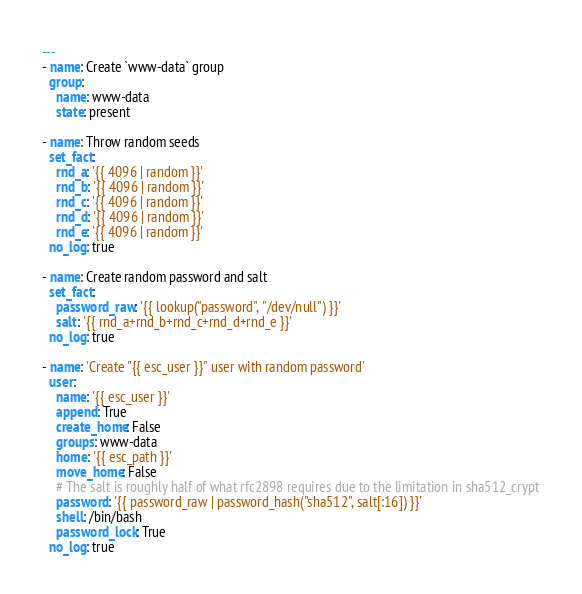Convert code to text. <code><loc_0><loc_0><loc_500><loc_500><_YAML_>---
- name: Create `www-data` group
  group:
    name: www-data
    state: present

- name: Throw random seeds
  set_fact:
    rnd_a: '{{ 4096 | random }}'
    rnd_b: '{{ 4096 | random }}'
    rnd_c: '{{ 4096 | random }}'
    rnd_d: '{{ 4096 | random }}'
    rnd_e: '{{ 4096 | random }}'
  no_log: true

- name: Create random password and salt
  set_fact:
    password_raw: '{{ lookup("password", "/dev/null") }}'
    salt: '{{ rnd_a+rnd_b+rnd_c+rnd_d+rnd_e }}'
  no_log: true

- name: 'Create "{{ esc_user }}" user with random password'
  user:
    name: '{{ esc_user }}'
    append: True
    create_home: False
    groups: www-data
    home: '{{ esc_path }}'
    move_home: False
    # The salt is roughly half of what rfc2898 requires due to the limitation in sha512_crypt
    password: '{{ password_raw | password_hash("sha512", salt[:16]) }}'
    shell: /bin/bash
    password_lock: True
  no_log: true
</code> 